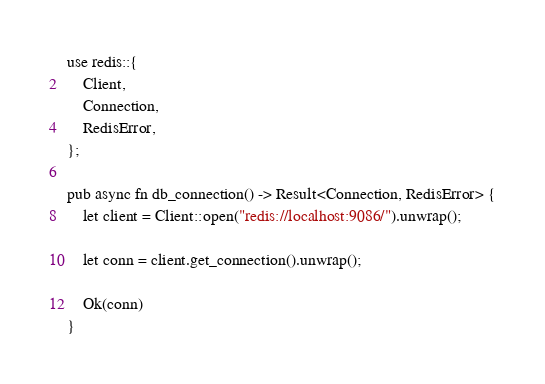Convert code to text. <code><loc_0><loc_0><loc_500><loc_500><_Rust_>use redis::{
    Client,
    Connection,
    RedisError,
};

pub async fn db_connection() -> Result<Connection, RedisError> {
    let client = Client::open("redis://localhost:9086/").unwrap();

    let conn = client.get_connection().unwrap();

    Ok(conn)
}
</code> 